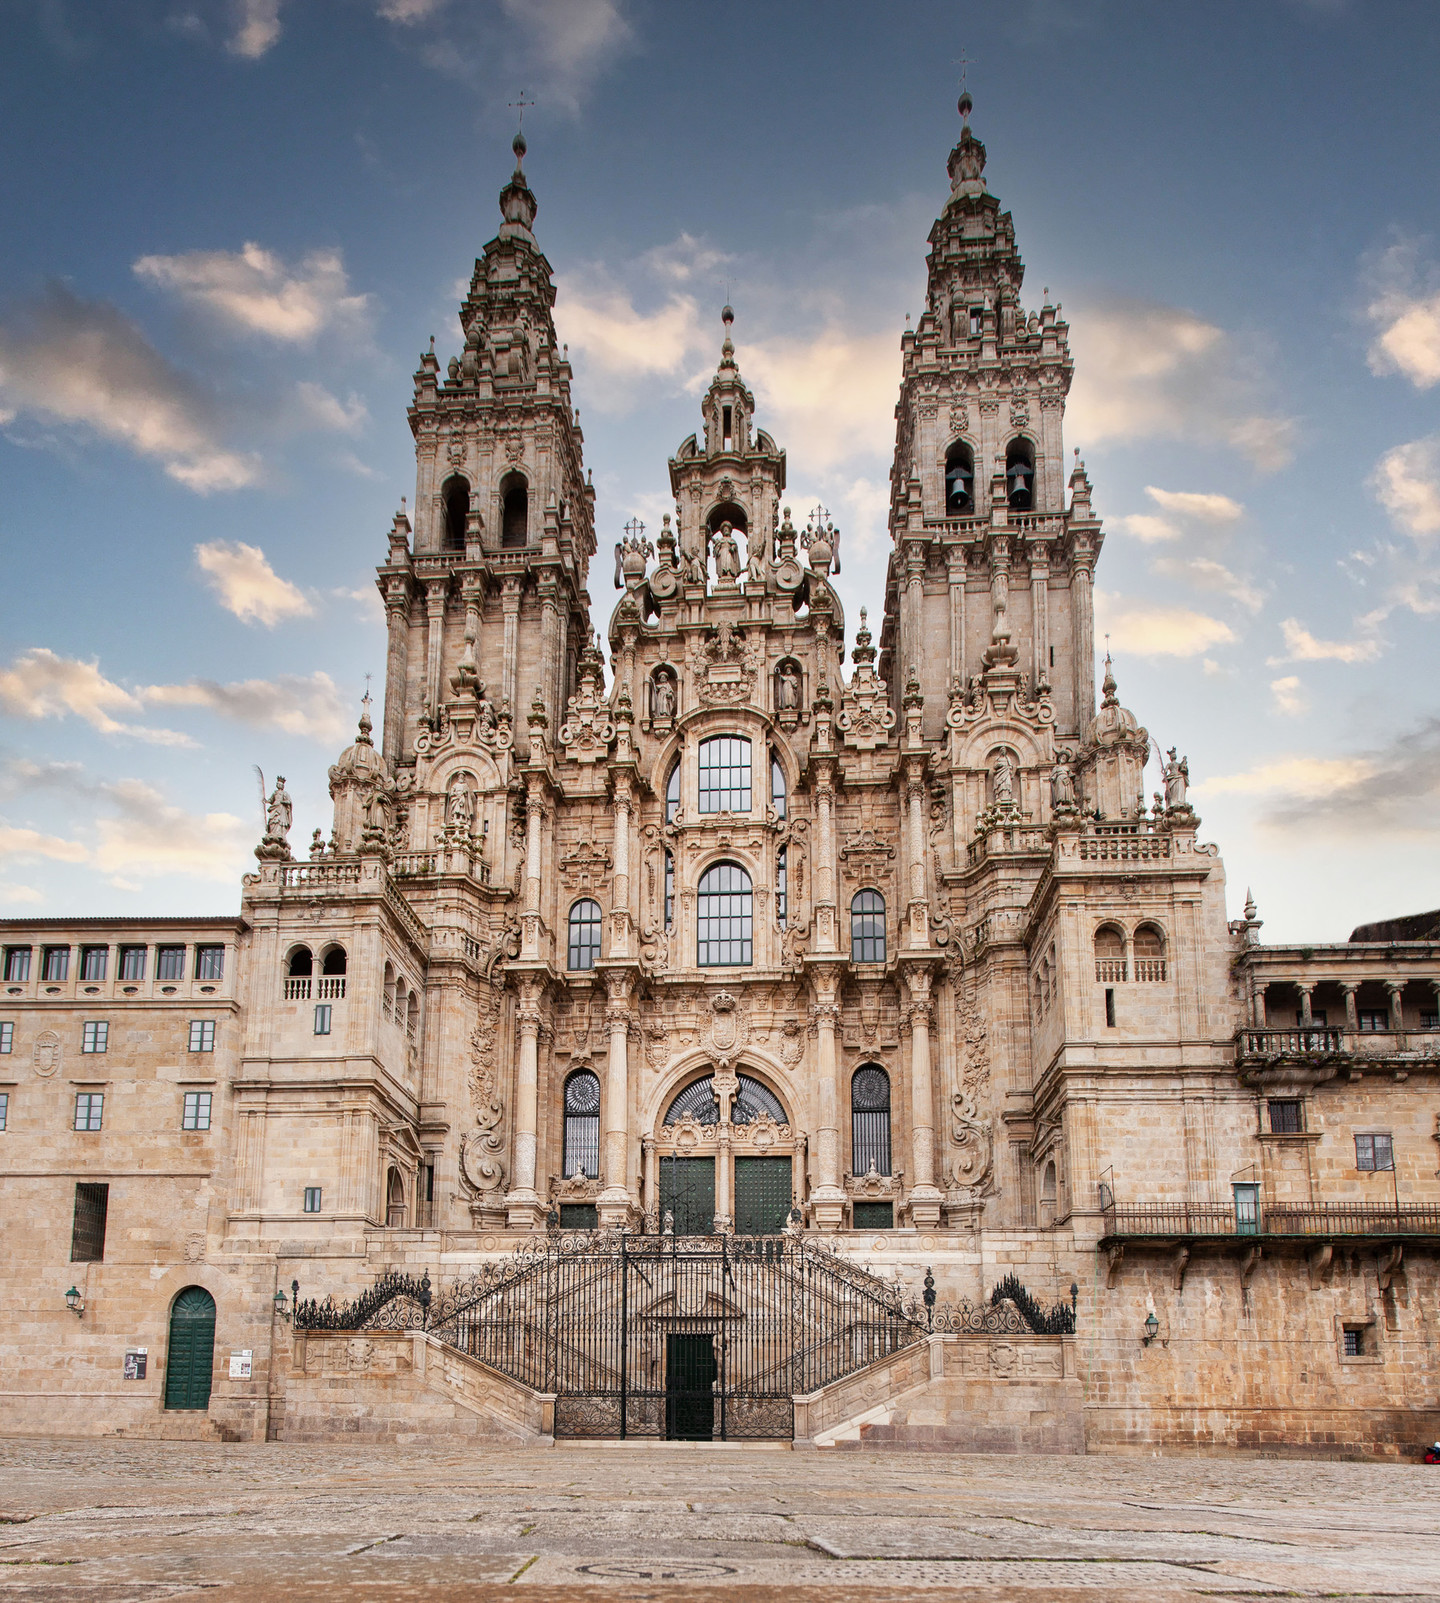Can you describe the architectural style of this building? The Cathedral Santiago De Compostela is primarily built in the Baroque architectural style, characterized by its exuberant, highly detailed, and ornamentally complex design. This style is evident in its grandiose facade that features intricate statues, elaborate carvings, and dynamic, undulating forms. The twin spires rise prominently, creating vertical emphasis, while the detailed sculptural elements reflect a high degree of craftsmanship and artistic flair typical of Baroque aesthetics. What historical significance does this cathedral hold? The Cathedral Santiago De Compostela holds immense historical and religious significance. It is reputed to be the final resting place of St. James the Apostle, making it one of the most important pilgrimage destinations in Christianity. The cathedral is the culmination point of the Camino de Santiago, a network of pilgrimage routes across Europe. Its construction began in the 11th century and has resulted in contributions from various architectural styles over the centuries, reflecting the evolving religious, cultural, and artistic history of Europe. Imagine you are a time traveler visiting this cathedral in the year 1500. What would you see and experience? As a time traveler visiting the Cathedral Santiago De Compostela in the year 1500, you would experience a profoundly spiritual and bustling atmosphere. The cathedral might still be undergoing additions and renovations, with craftsmen and artists meticulously working on the intricate facades and interior decor. Pilgrims from various parts of Europe would gather, each having taken a long, arduous journey on foot to reach this holy site. The atmosphere would be filled with the sounds of prayer, hymns, and the bustling of medieval life. You might see the ancient ritual of the botafumeiro, a large incense burner swung during the mass, creating an awe-inspiring spectacle. 